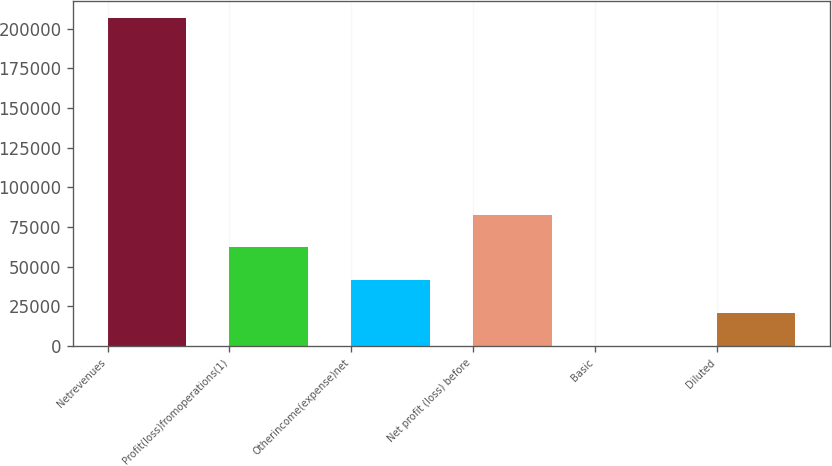Convert chart. <chart><loc_0><loc_0><loc_500><loc_500><bar_chart><fcel>Netrevenues<fcel>Profit(loss)fromoperations(1)<fcel>Otherincome(expense)net<fcel>Net profit (loss) before<fcel>Basic<fcel>Diluted<nl><fcel>207125<fcel>62137.5<fcel>41425<fcel>82850<fcel>0.02<fcel>20712.5<nl></chart> 